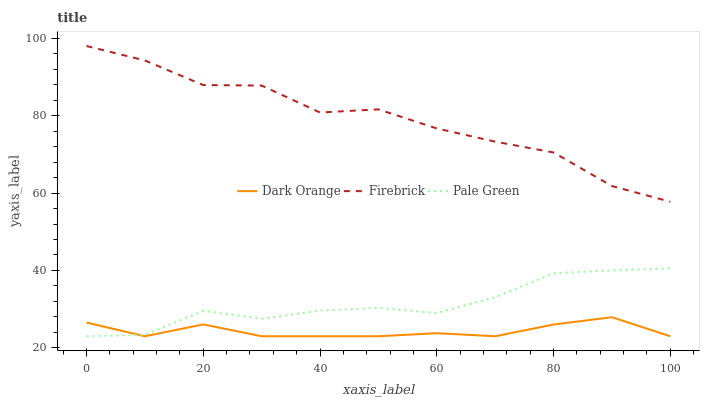Does Dark Orange have the minimum area under the curve?
Answer yes or no. Yes. Does Firebrick have the maximum area under the curve?
Answer yes or no. Yes. Does Pale Green have the minimum area under the curve?
Answer yes or no. No. Does Pale Green have the maximum area under the curve?
Answer yes or no. No. Is Dark Orange the smoothest?
Answer yes or no. Yes. Is Firebrick the roughest?
Answer yes or no. Yes. Is Pale Green the smoothest?
Answer yes or no. No. Is Pale Green the roughest?
Answer yes or no. No. Does Dark Orange have the lowest value?
Answer yes or no. Yes. Does Firebrick have the lowest value?
Answer yes or no. No. Does Firebrick have the highest value?
Answer yes or no. Yes. Does Pale Green have the highest value?
Answer yes or no. No. Is Dark Orange less than Firebrick?
Answer yes or no. Yes. Is Firebrick greater than Dark Orange?
Answer yes or no. Yes. Does Pale Green intersect Dark Orange?
Answer yes or no. Yes. Is Pale Green less than Dark Orange?
Answer yes or no. No. Is Pale Green greater than Dark Orange?
Answer yes or no. No. Does Dark Orange intersect Firebrick?
Answer yes or no. No. 